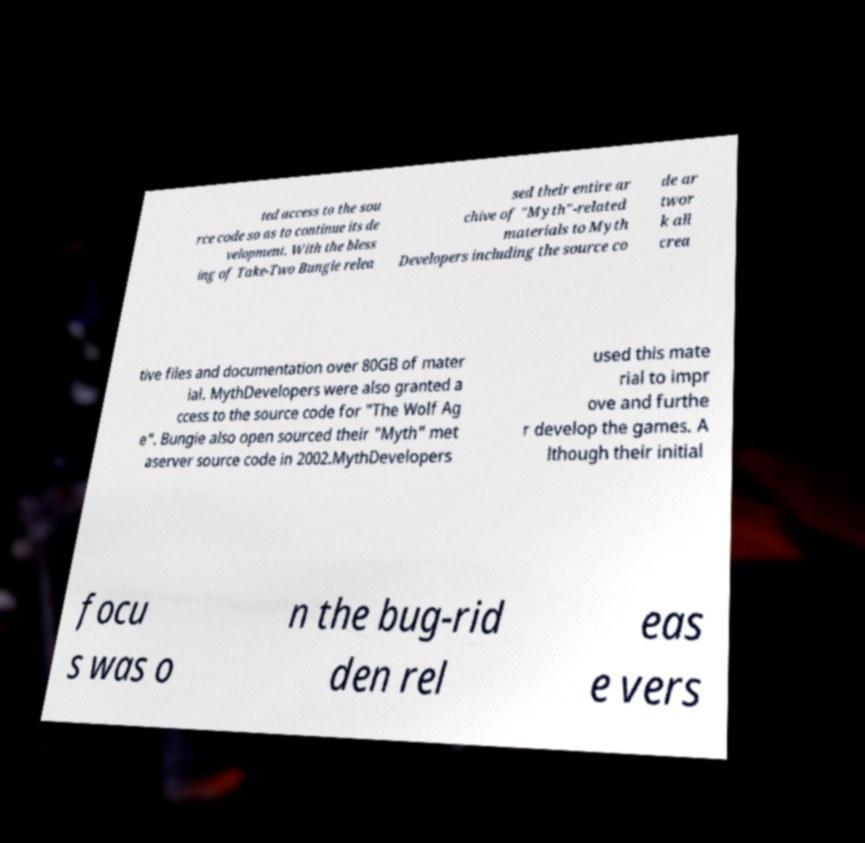Please identify and transcribe the text found in this image. ted access to the sou rce code so as to continue its de velopment. With the bless ing of Take-Two Bungie relea sed their entire ar chive of "Myth"-related materials to Myth Developers including the source co de ar twor k all crea tive files and documentation over 80GB of mater ial. MythDevelopers were also granted a ccess to the source code for "The Wolf Ag e". Bungie also open sourced their "Myth" met aserver source code in 2002.MythDevelopers used this mate rial to impr ove and furthe r develop the games. A lthough their initial focu s was o n the bug-rid den rel eas e vers 